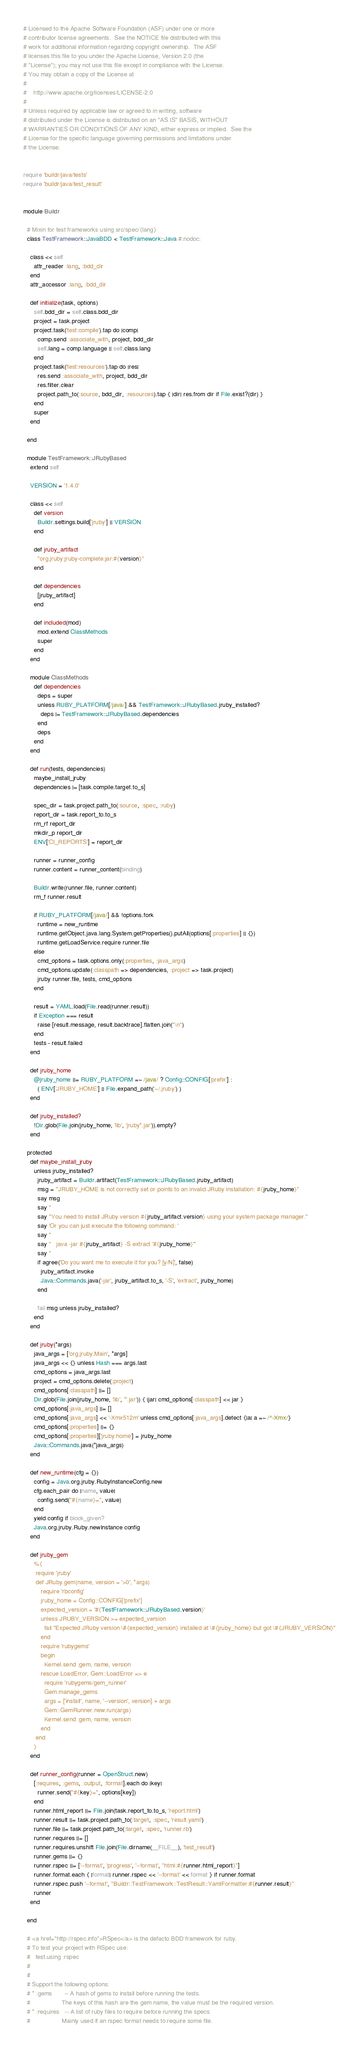Convert code to text. <code><loc_0><loc_0><loc_500><loc_500><_Ruby_># Licensed to the Apache Software Foundation (ASF) under one or more
# contributor license agreements.  See the NOTICE file distributed with this
# work for additional information regarding copyright ownership.  The ASF
# licenses this file to you under the Apache License, Version 2.0 (the
# "License"); you may not use this file except in compliance with the License.
# You may obtain a copy of the License at
#
#    http://www.apache.org/licenses/LICENSE-2.0
#
# Unless required by applicable law or agreed to in writing, software
# distributed under the License is distributed on an "AS IS" BASIS, WITHOUT
# WARRANTIES OR CONDITIONS OF ANY KIND, either express or implied.  See the
# License for the specific language governing permissions and limitations under
# the License.


require 'buildr/java/tests'
require 'buildr/java/test_result'


module Buildr

  # Mixin for test frameworks using src/spec/{lang}
  class TestFramework::JavaBDD < TestFramework::Java #:nodoc:

    class << self
      attr_reader :lang, :bdd_dir
    end
    attr_accessor :lang, :bdd_dir

    def initialize(task, options)
      self.bdd_dir = self.class.bdd_dir
      project = task.project
      project.task('test:compile').tap do |comp| 
        comp.send :associate_with, project, bdd_dir
        self.lang = comp.language || self.class.lang
      end
      project.task('test:resources').tap do |res|
        res.send :associate_with, project, bdd_dir
        res.filter.clear
        project.path_to(:source, bdd_dir, :resources).tap { |dir| res.from dir if File.exist?(dir) }
      end
      super
    end
    
  end

  module TestFramework::JRubyBased
    extend self

    VERSION = '1.4.0'

    class << self
      def version
        Buildr.settings.build['jruby'] || VERSION
      end

      def jruby_artifact
        "org.jruby:jruby-complete:jar:#{version}"
      end
      
      def dependencies
        [jruby_artifact]
      end

      def included(mod)
        mod.extend ClassMethods
        super
      end
    end

    module ClassMethods
      def dependencies
        deps = super
        unless RUBY_PLATFORM[/java/] && TestFramework::JRubyBased.jruby_installed?
          deps |= TestFramework::JRubyBased.dependencies
        end
        deps
      end
    end

    def run(tests, dependencies)
      maybe_install_jruby
      dependencies |= [task.compile.target.to_s]
      
      spec_dir = task.project.path_to(:source, :spec, :ruby)
      report_dir = task.report_to.to_s
      rm_rf report_dir
      mkdir_p report_dir
      ENV['CI_REPORTS'] = report_dir

      runner = runner_config
      runner.content = runner_content(binding)
      
      Buildr.write(runner.file, runner.content)
      rm_f runner.result

      if RUBY_PLATFORM[/java/] && !options.fork
        runtime = new_runtime
        runtime.getObject.java.lang.System.getProperties().putAll(options[:properties] || {})
        runtime.getLoadService.require runner.file
      else
        cmd_options = task.options.only(:properties, :java_args)
        cmd_options.update(:classpath => dependencies, :project => task.project)
        jruby runner.file, tests, cmd_options
      end
      
      result = YAML.load(File.read(runner.result))
      if Exception === result
        raise [result.message, result.backtrace].flatten.join("\n")
      end
      tests - result.failed
    end

    def jruby_home
      @jruby_home ||= RUBY_PLATFORM =~ /java/ ? Config::CONFIG['prefix'] : 
        ( ENV['JRUBY_HOME'] || File.expand_path('~/.jruby') )
    end

    def jruby_installed?
      !Dir.glob(File.join(jruby_home, 'lib', 'jruby*.jar')).empty?
    end
    
  protected
    def maybe_install_jruby
      unless jruby_installed?
        jruby_artifact = Buildr.artifact(TestFramework::JRubyBased.jruby_artifact)
        msg = "JRUBY_HOME is not correctly set or points to an invalid JRuby installation: #{jruby_home}"
        say msg
        say ''
        say "You need to install JRuby version #{jruby_artifact.version} using your system package manager."
        say 'Or you can just execute the following command: '
        say ''
        say "   java -jar #{jruby_artifact} -S extract '#{jruby_home}'"
        say ''
        if agree('Do you want me to execute it for you? [y/N]', false)
          jruby_artifact.invoke
          Java::Commands.java('-jar', jruby_artifact.to_s, '-S', 'extract', jruby_home)
        end
        
        fail msg unless jruby_installed?
      end
    end

    def jruby(*args)
      java_args = ['org.jruby.Main', *args]
      java_args << {} unless Hash === args.last
      cmd_options = java_args.last
      project = cmd_options.delete(:project)
      cmd_options[:classpath] ||= []
      Dir.glob(File.join(jruby_home, 'lib', '*.jar')) { |jar| cmd_options[:classpath] << jar }
      cmd_options[:java_args] ||= []
      cmd_options[:java_args] << '-Xmx512m' unless cmd_options[:java_args].detect {|a| a =~ /^-Xmx/}
      cmd_options[:properties] ||= {}
      cmd_options[:properties]['jruby.home'] = jruby_home
      Java::Commands.java(*java_args)
    end

    def new_runtime(cfg = {})
      config = Java.org.jruby.RubyInstanceConfig.new
      cfg.each_pair do |name, value|
        config.send("#{name}=", value)
      end
      yield config if block_given?
      Java.org.jruby.Ruby.newInstance config
    end
    
    def jruby_gem
      %{
       require 'jruby'
       def JRuby.gem(name, version = '>0', *args)
          require 'rbconfig'
          jruby_home = Config::CONFIG['prefix']
          expected_version = '#{TestFramework::JRubyBased.version}'
          unless JRUBY_VERSION >= expected_version
            fail "Expected JRuby version \#{expected_version} installed at \#{jruby_home} but got \#{JRUBY_VERSION}"
          end
          require 'rubygems'
          begin
            Kernel.send :gem, name, version
          rescue LoadError, Gem::LoadError => e
            require 'rubygems/gem_runner'
            Gem.manage_gems
            args = ['install', name, '--version', version] + args
            Gem::GemRunner.new.run(args)
            Kernel.send :gem, name, version
          end
       end
      }
    end

    def runner_config(runner = OpenStruct.new)
      [:requires, :gems, :output, :format].each do |key|
        runner.send("#{key}=", options[key])
      end
      runner.html_report ||= File.join(task.report_to.to_s, 'report.html')
      runner.result ||= task.project.path_to(:target, :spec, 'result.yaml')
      runner.file ||= task.project.path_to(:target, :spec, 'runner.rb')
      runner.requires ||= []
      runner.requires.unshift File.join(File.dirname(__FILE__), 'test_result')
      runner.gems ||= {}
      runner.rspec ||= ['--format', 'progress', '--format', "html:#{runner.html_report}"]
      runner.format.each { |format| runner.rspec << '--format' << format } if runner.format
      runner.rspec.push '--format', "Buildr::TestFramework::TestResult::YamlFormatter:#{runner.result}"
      runner
    end
    
  end

  # <a href="http://rspec.info">RSpec</a> is the defacto BDD framework for ruby.
  # To test your project with RSpec use:
  #   test.using :rspec
  #
  #
  # Support the following options:
  # * :gems       -- A hash of gems to install before running the tests.
  #                  The keys of this hash are the gem name, the value must be the required version.
  # * :requires   -- A list of ruby files to require before running the specs
  #                  Mainly used if an rspec format needs to require some file.</code> 